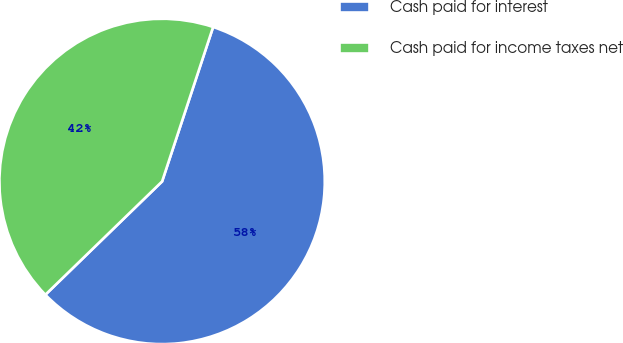Convert chart to OTSL. <chart><loc_0><loc_0><loc_500><loc_500><pie_chart><fcel>Cash paid for interest<fcel>Cash paid for income taxes net<nl><fcel>57.66%<fcel>42.34%<nl></chart> 